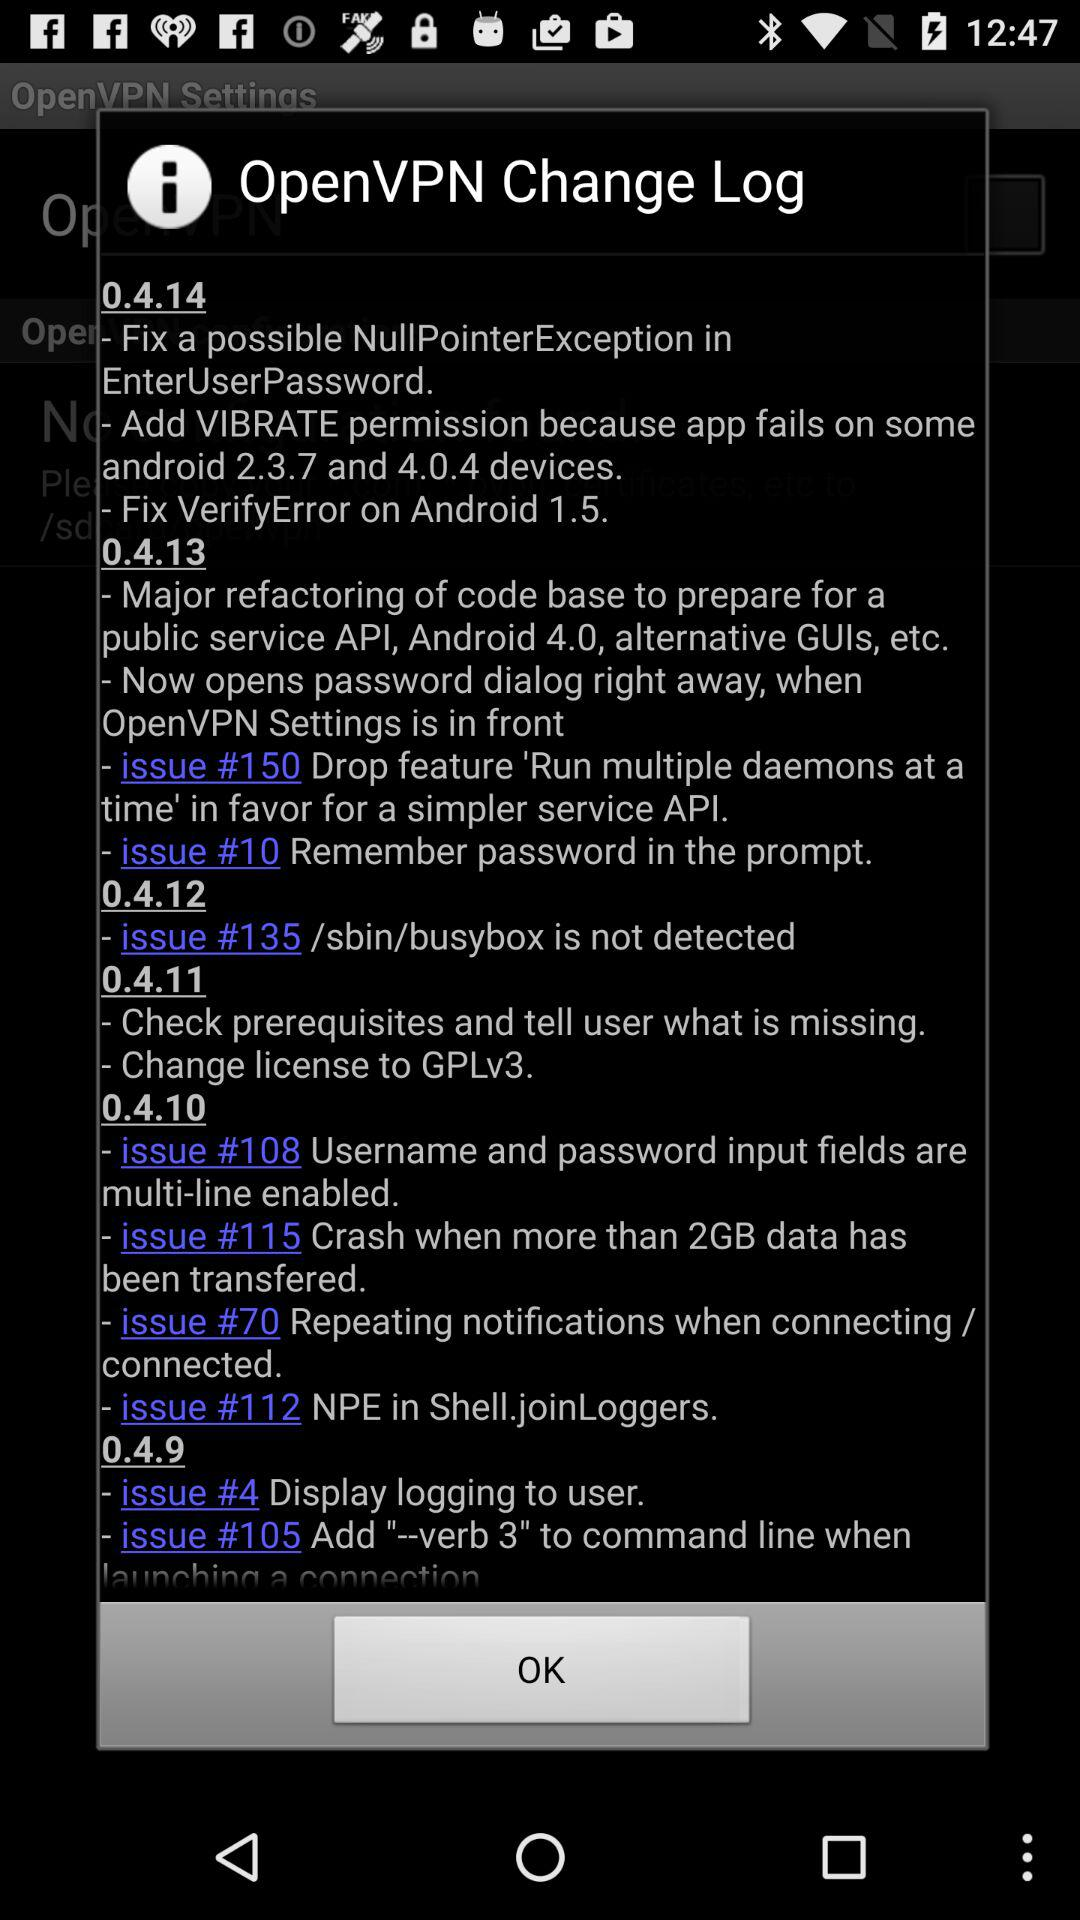When was "Open VPN Change Log" last updated?
When the provided information is insufficient, respond with <no answer>. <no answer> 